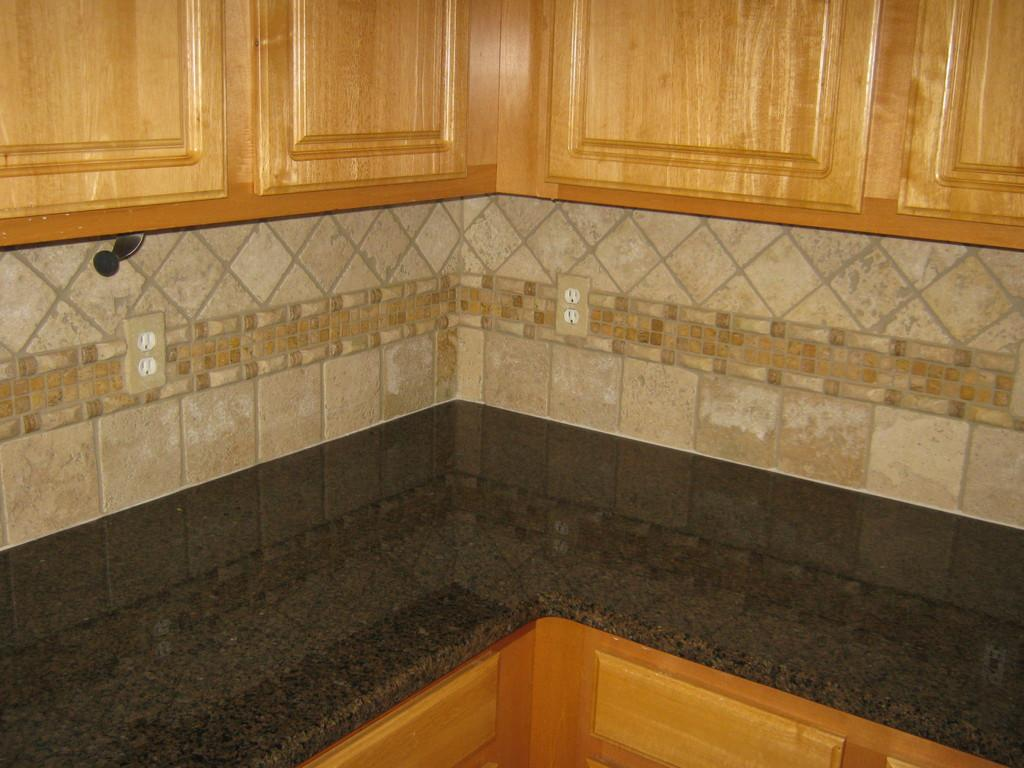What type of surface is at the bottom of the image? There is a countertop at the bottom of the image. What type of storage units are at the top of the image? There are cupboards at the top of the image. What type of structure is visible in the image? There is a wall visible in the image. How many women are resting on the countertop in the image? There are no women present in the image, and the countertop is not a place for resting. 